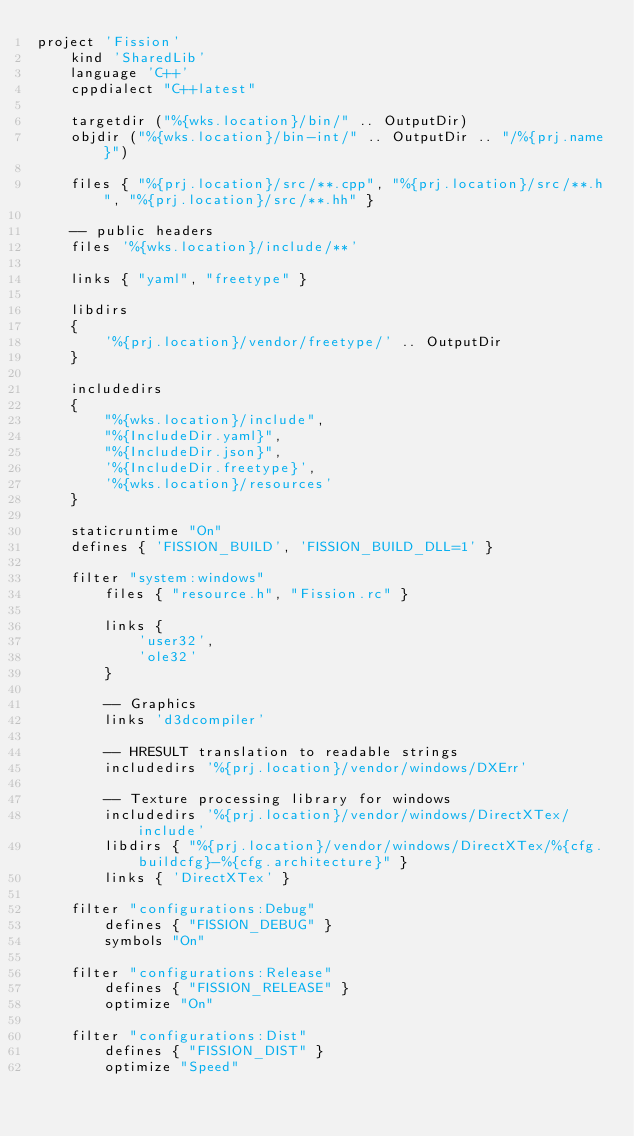Convert code to text. <code><loc_0><loc_0><loc_500><loc_500><_Lua_>project 'Fission'
    kind 'SharedLib'
    language 'C++'
    cppdialect "C++latest"

    targetdir ("%{wks.location}/bin/" .. OutputDir)
	objdir ("%{wks.location}/bin-int/" .. OutputDir .. "/%{prj.name}")

    files { "%{prj.location}/src/**.cpp", "%{prj.location}/src/**.h", "%{prj.location}/src/**.hh" }

    -- public headers
    files '%{wks.location}/include/**'

    links { "yaml", "freetype" }

    libdirs
    {
        '%{prj.location}/vendor/freetype/' .. OutputDir
    }

	includedirs
	{
        "%{wks.location}/include",
        "%{IncludeDir.yaml}",
        "%{IncludeDir.json}",
        '%{IncludeDir.freetype}',
        '%{wks.location}/resources'
	}
    
    staticruntime "On"
    defines { 'FISSION_BUILD', 'FISSION_BUILD_DLL=1' }
    
    filter "system:windows"
        files { "resource.h", "Fission.rc" }

        links { 
            'user32',
            'ole32'
        }

        -- Graphics
        links 'd3dcompiler'

        -- HRESULT translation to readable strings
        includedirs '%{prj.location}/vendor/windows/DXErr'
    
        -- Texture processing library for windows
        includedirs '%{prj.location}/vendor/windows/DirectXTex/include'
        libdirs { "%{prj.location}/vendor/windows/DirectXTex/%{cfg.buildcfg}-%{cfg.architecture}" }
        links { 'DirectXTex' }

    filter "configurations:Debug"
        defines { "FISSION_DEBUG" }
        symbols "On"

    filter "configurations:Release"
        defines { "FISSION_RELEASE" }
        optimize "On"

    filter "configurations:Dist"
        defines { "FISSION_DIST" }
        optimize "Speed"</code> 